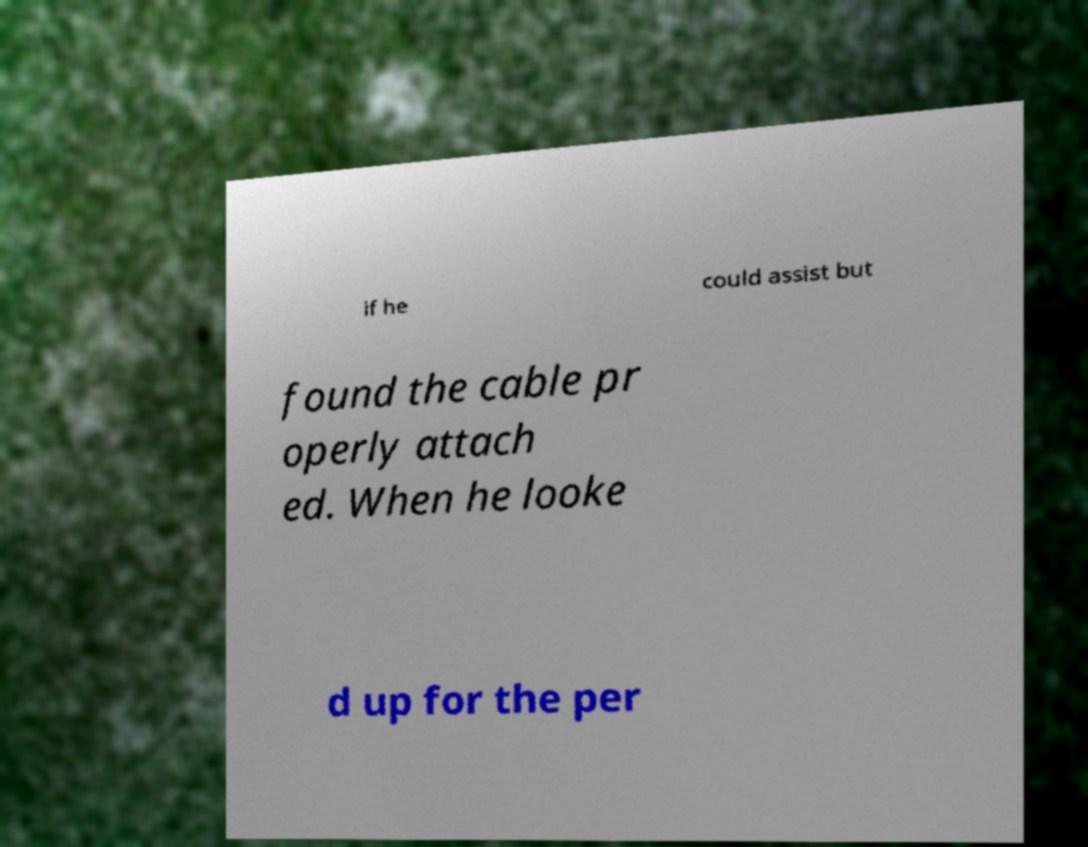Could you extract and type out the text from this image? if he could assist but found the cable pr operly attach ed. When he looke d up for the per 